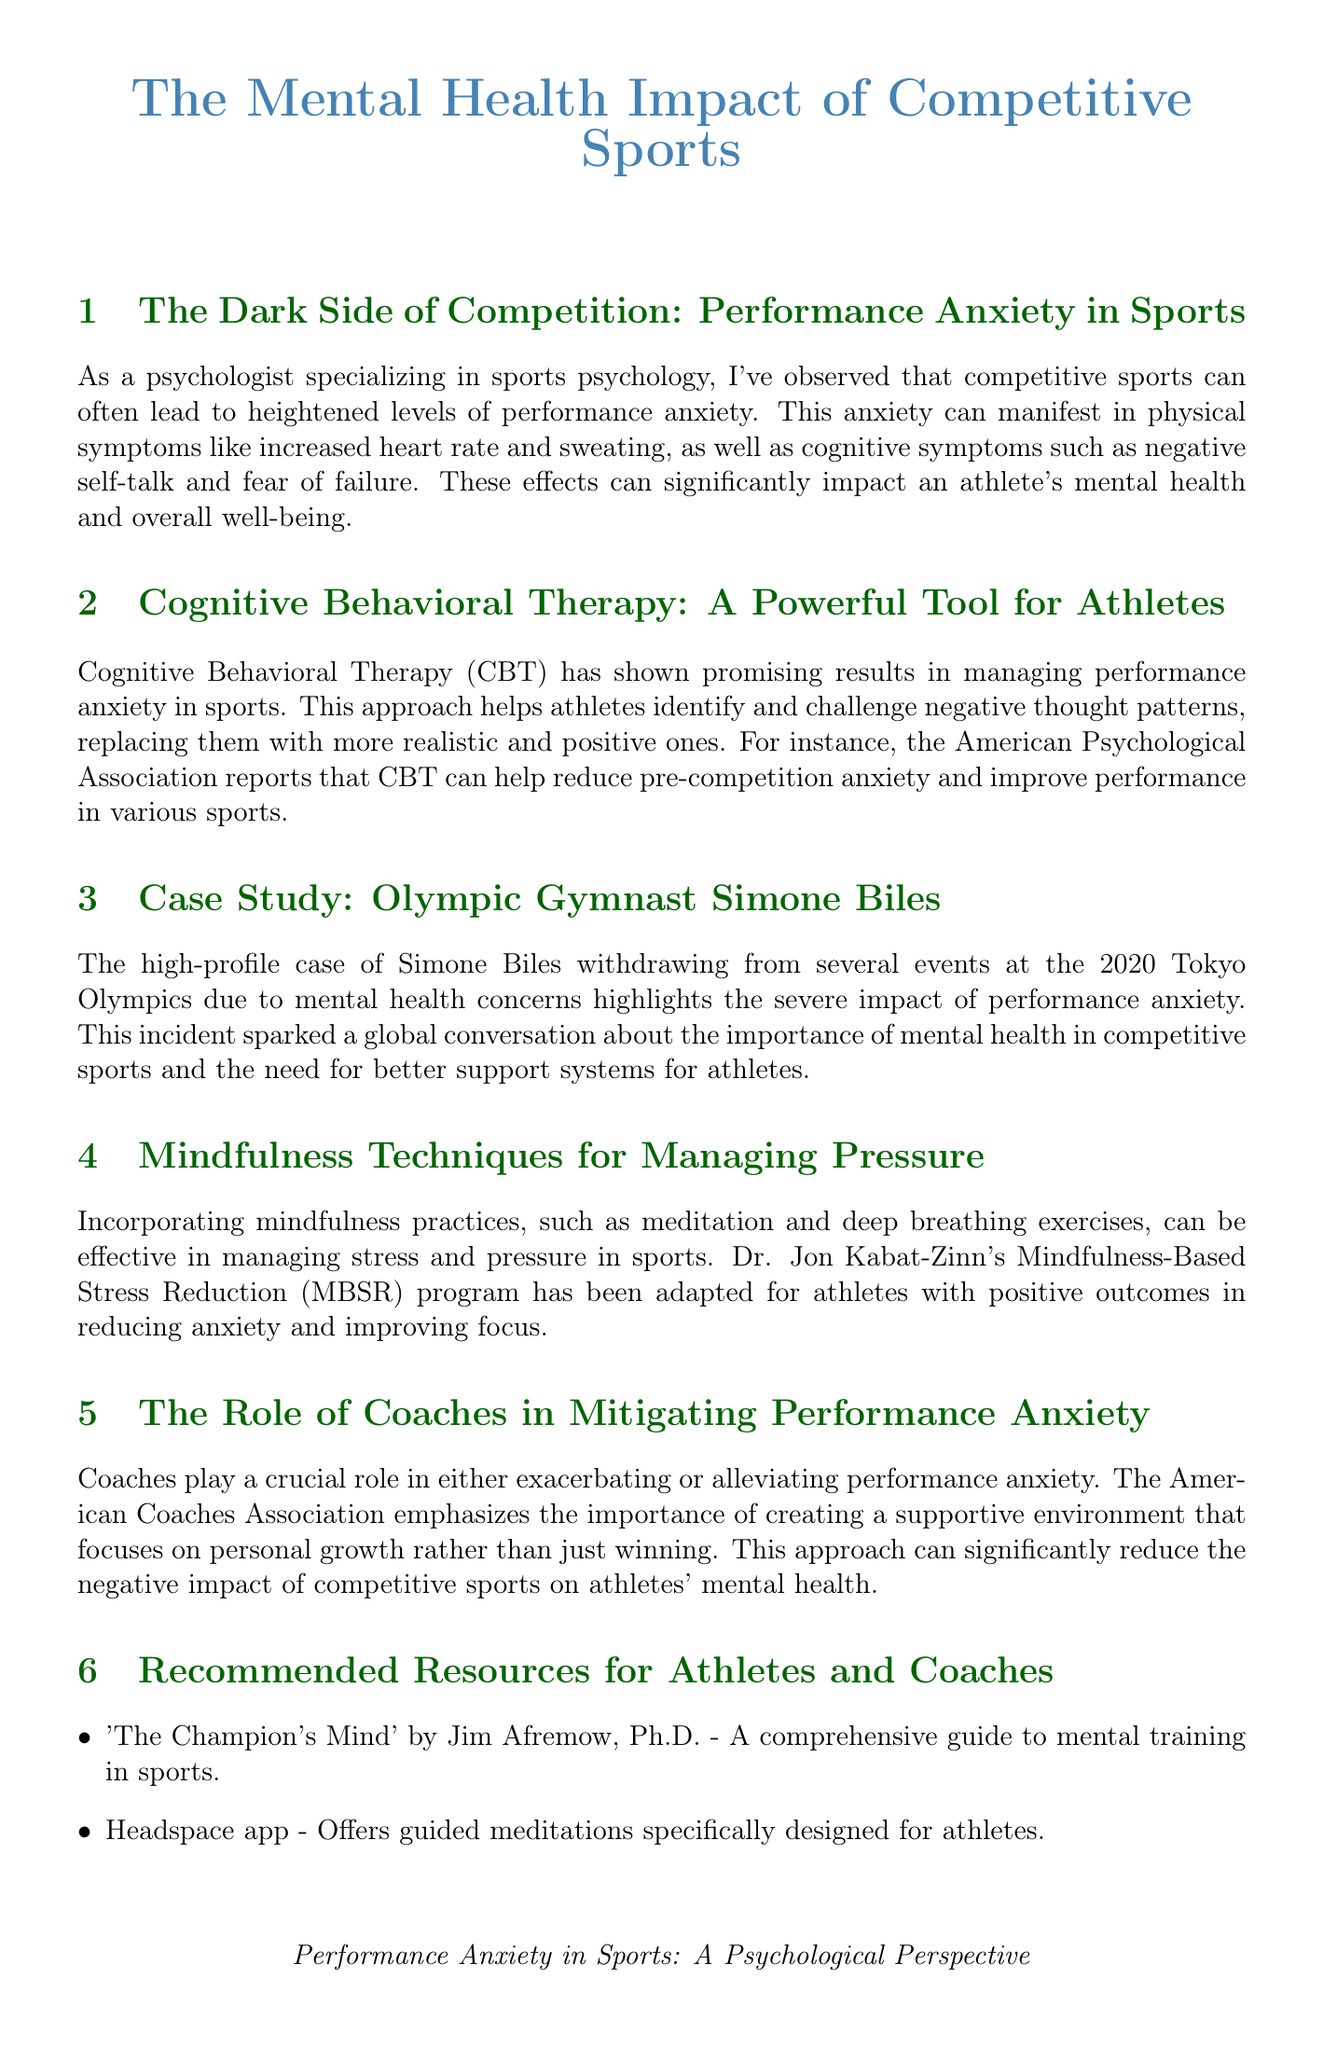what is the main topic of the newsletter? The main topic is the impact of performance anxiety on athletes and how to manage it.
Answer: Performance Anxiety in Sports who is a notable case discussed in the newsletter? The newsletter discusses Simone Biles' withdrawal due to mental health concerns.
Answer: Simone Biles what therapy is highlighted as effective for managing performance anxiety? The newsletter states that Cognitive Behavioral Therapy is effective.
Answer: Cognitive Behavioral Therapy what impact can performance anxiety have on athletes? Performance anxiety can lead to physical symptoms like increased heart rate and sweating, and cognitive symptoms such as negative self-talk.
Answer: Physical and cognitive symptoms what mindfulness practice is recommended for managing stress? The newsletter recommends meditation and deep breathing exercises.
Answer: Meditation and deep breathing exercises which organization emphasizes the role of supportive coaching? The American Coaches Association emphasizes this role.
Answer: American Coaches Association what resource is recommended for mental training in sports? The newsletter recommends 'The Champion's Mind' by Jim Afremow, Ph.D.
Answer: 'The Champion's Mind' how does the newsletter suggest cognitive behavioral therapy helps athletes? It helps athletes identify and challenge negative thought patterns.
Answer: Identify and challenge negative thought patterns what program is adapted for athletes to reduce anxiety? The newsletter mentions Dr. Jon Kabat-Zinn's Mindfulness-Based Stress Reduction program.
Answer: Mindfulness-Based Stress Reduction 